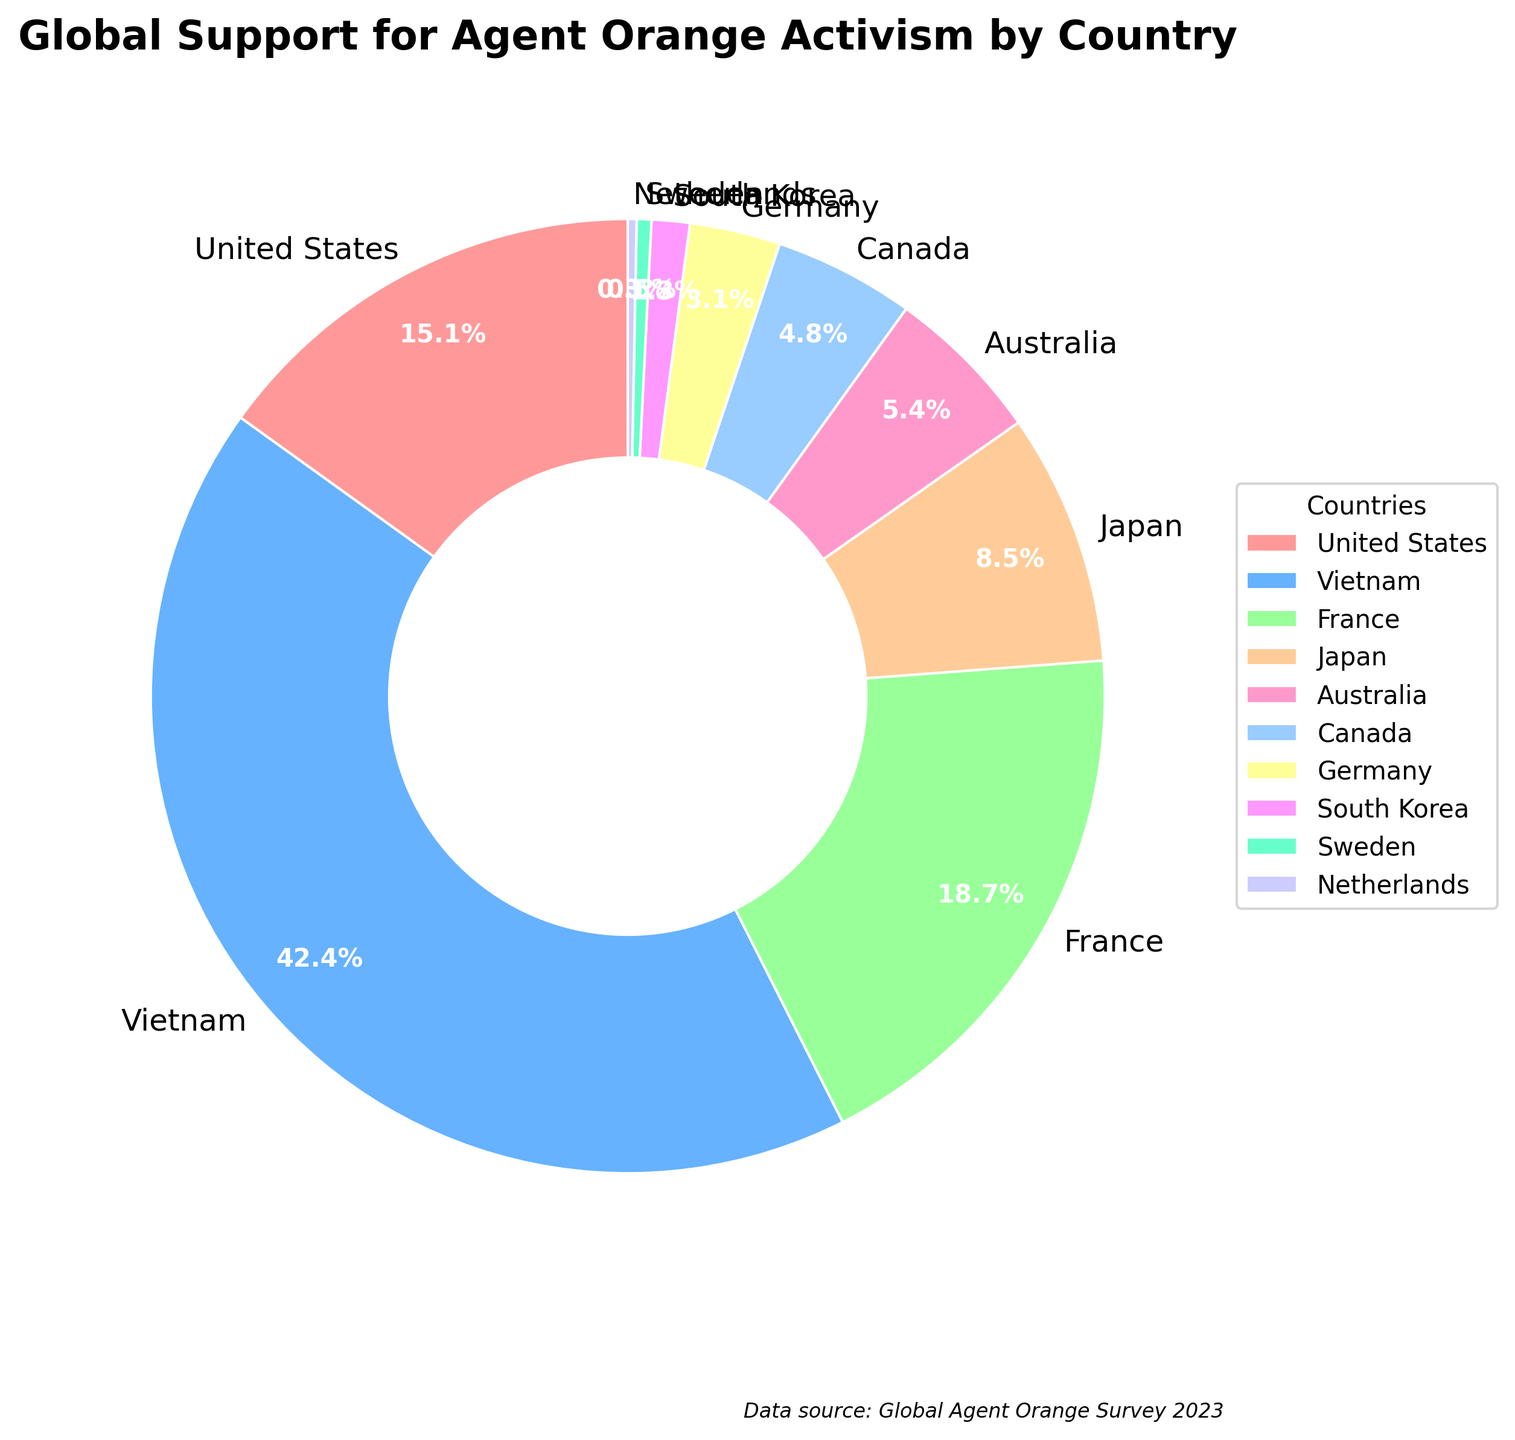Which country has the highest percentage of support for Agent Orange activism? The country with the largest slice in the pie chart represents the highest percentage of support. Vietnam has the largest portion.
Answer: Vietnam What is the combined support percentage of the United States and France? Look for the percentages of the United States and France on the chart. Add them together: 15.2% (US) + 18.9% (France) = 34.1%.
Answer: 34.1% How much more support does Vietnam have compared to Japan? Identify the support percentages for Vietnam and Japan. Subtract Japan's percentage from Vietnam's: 42.7% - 8.6% = 34.1%.
Answer: 34.1% Which country has the smallest percentage of support? Find the smallest slice on the pie chart. The Netherlands has the smallest portion at 0.3%.
Answer: Netherlands What is the average support percentage of all the countries listed? Sum all the percentages and divide by the number of countries. (15.2 + 42.7 + 18.9 + 8.6 + 5.4 + 4.8 + 3.1 + 1.3 + 0.5 + 0.3) / 10 = 10.08%.
Answer: 10.08% Which countries have less than 5% support for Agent Orange activism? Identify the countries whose slices correspond to values less than 5%. They are Canada, Germany, South Korea, Sweden, and the Netherlands.
Answer: Canada, Germany, South Korea, Sweden, Netherlands What is the difference in support percentages between Australia and South Korea? Look at the support percentages for both Australia and South Korea. Subtract South Korea's percentage from Australia's: 5.4% - 1.3% = 4.1%.
Answer: 4.1% What percentage of total global support is contributed by France and Japan combined? Sum the support percentages of France and Japan. (18.9 + 8.6) = 27.5%.
Answer: 27.5% Which two countries combined have a support percentage closest to Vietnam's support? Identify pairs of countries and their combined support percentages. The pair of France and United States (18.9% + 15.2%) = 34.1% is closest to Vietnam's 42.7%, without exceeding it.
Answer: France and United States What is the total support percentage of countries with more than 10% support individually? Identify and sum the percentages of countries with more than 10% support each. United States, Vietnam, and France: (15.2 + 42.7 + 18.9) = 76.8%.
Answer: 76.8% 